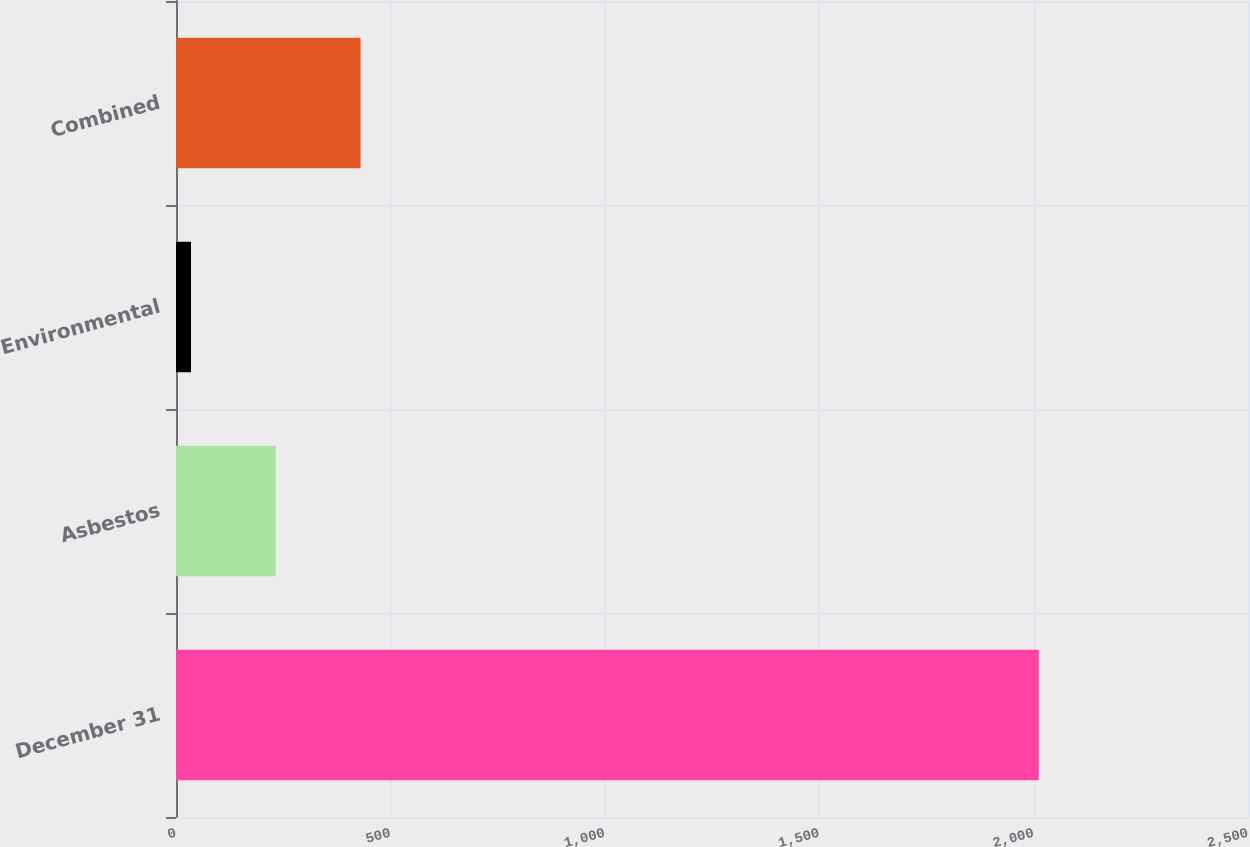<chart> <loc_0><loc_0><loc_500><loc_500><bar_chart><fcel>December 31<fcel>Asbestos<fcel>Environmental<fcel>Combined<nl><fcel>2012<fcel>232.7<fcel>35<fcel>430.4<nl></chart> 